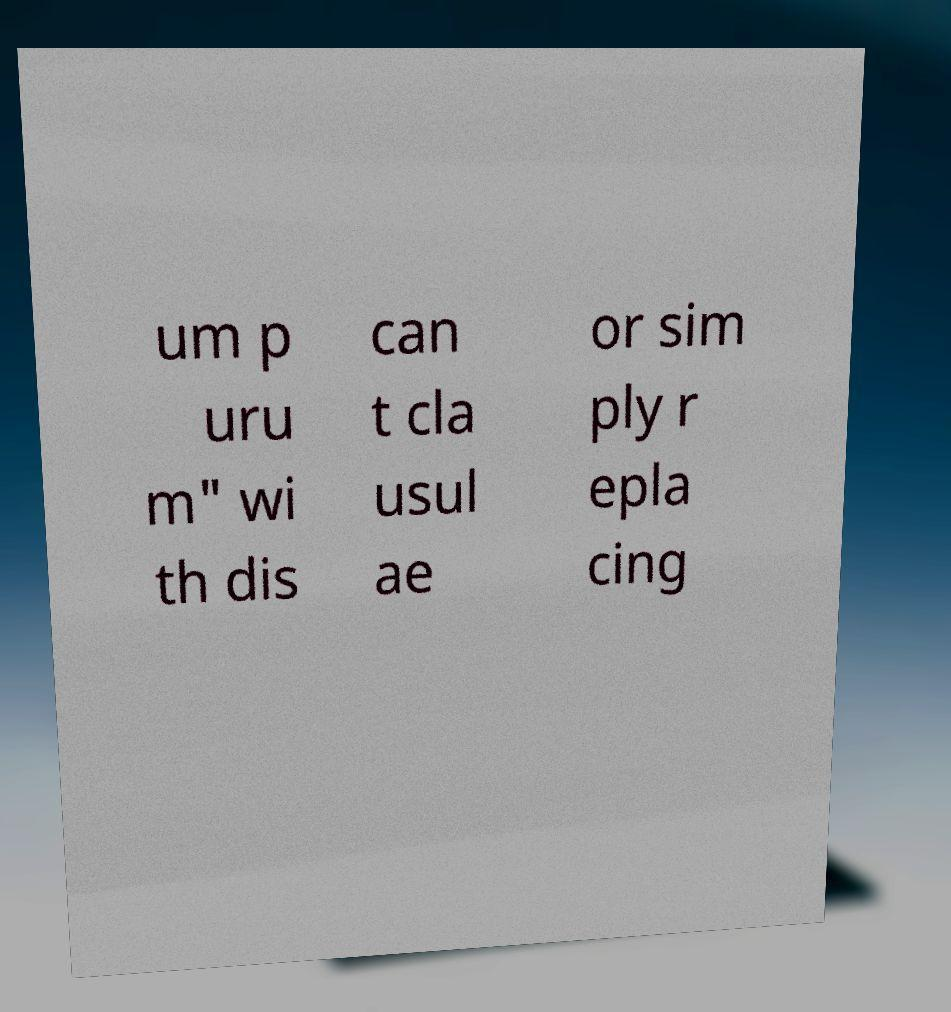Could you assist in decoding the text presented in this image and type it out clearly? um p uru m" wi th dis can t cla usul ae or sim ply r epla cing 